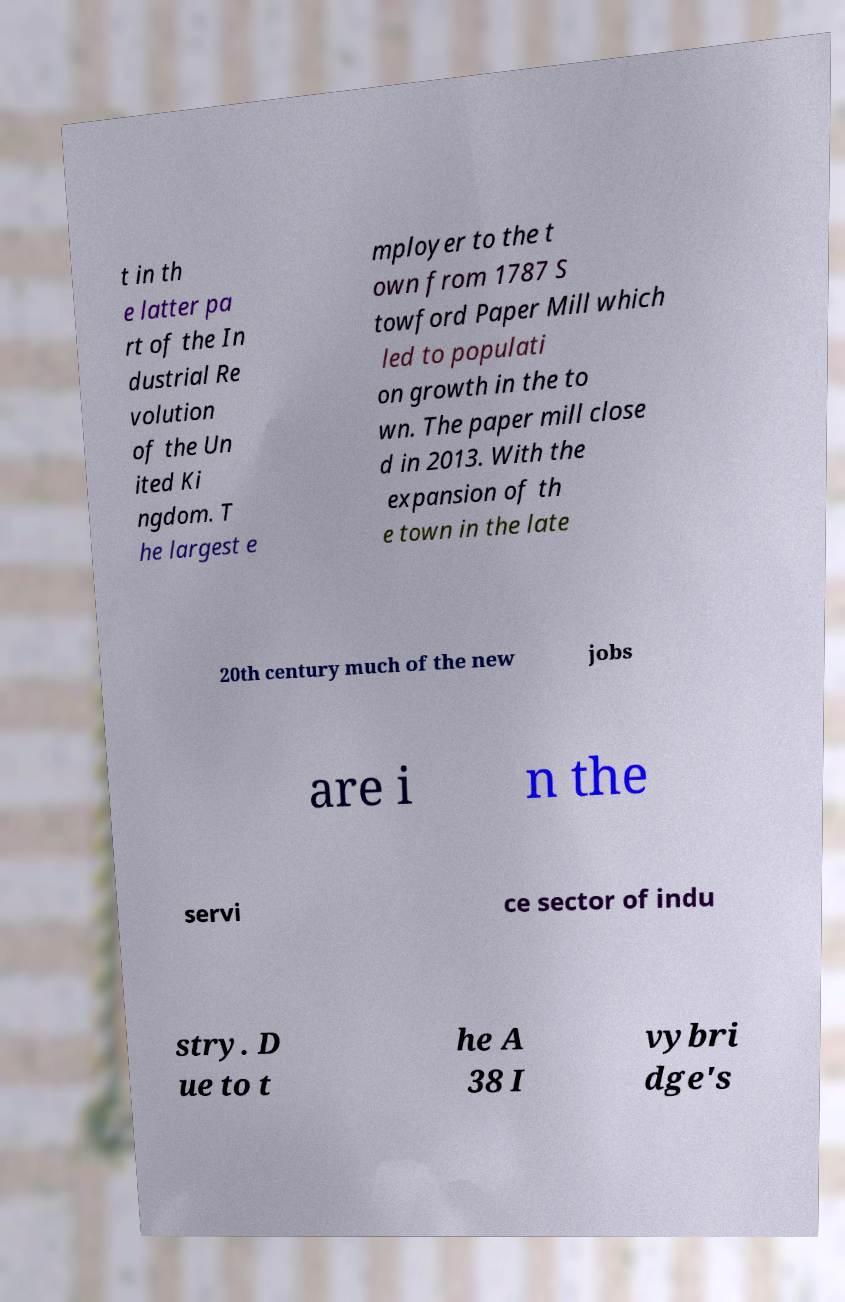Please identify and transcribe the text found in this image. t in th e latter pa rt of the In dustrial Re volution of the Un ited Ki ngdom. T he largest e mployer to the t own from 1787 S towford Paper Mill which led to populati on growth in the to wn. The paper mill close d in 2013. With the expansion of th e town in the late 20th century much of the new jobs are i n the servi ce sector of indu stry. D ue to t he A 38 I vybri dge's 